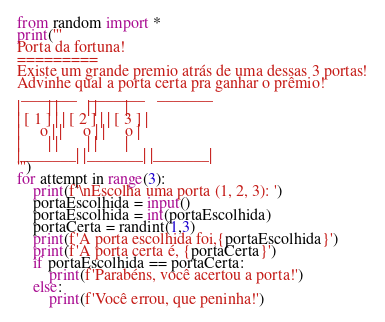Convert code to text. <code><loc_0><loc_0><loc_500><loc_500><_Python_>from random import *
print('''
Porta da fortuna!
=========
Existe um grande premio atrás de uma dessas 3 portas!
Advinhe qual a porta certa pra ganhar o prêmio!
 _______   _______   _______
|       | |       | |       |
| [ 1 ] | | [ 2 ] | | [ 3 ] |
|     o | |     o | |     o |
|       | |       | |       |
|_______| |_______| |_______|
''')
for attempt in range(3):
    print(f'\nEscolha uma porta (1, 2, 3): ')
    portaEscolhida = input()
    portaEscolhida = int(portaEscolhida)
    portaCerta = randint(1,3)
    print(f'A porta escolhida foi,{portaEscolhida}')
    print(f'A porta certa é, {portaCerta}')
    if portaEscolhida == portaCerta:
        print(f'Parabéns, você acertou a porta!')
    else:
        print(f'Você errou, que peninha!')
</code> 